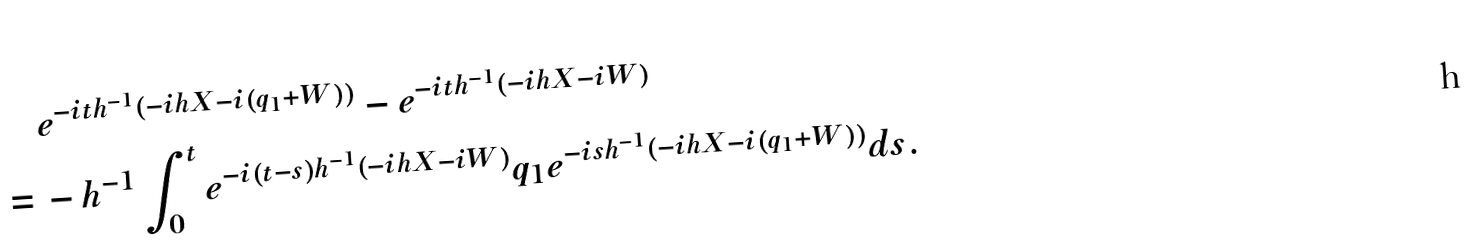Convert formula to latex. <formula><loc_0><loc_0><loc_500><loc_500>& \, e ^ { - i t h ^ { - 1 } ( - i h X - i ( q _ { 1 } + W ) ) } - e ^ { - i t h ^ { - 1 } ( - i h X - i W ) } \\ = & \, - h ^ { - 1 } \int _ { 0 } ^ { t } e ^ { - i ( t - s ) h ^ { - 1 } ( - i h X - i W ) } q _ { 1 } e ^ { - i s h ^ { - 1 } ( - i h X - i ( q _ { 1 } + W ) ) } d s .</formula> 